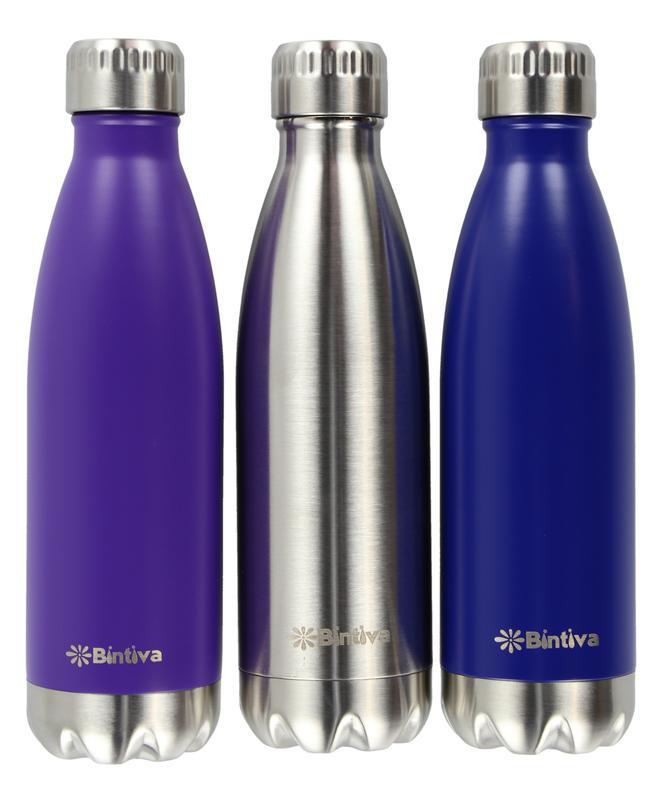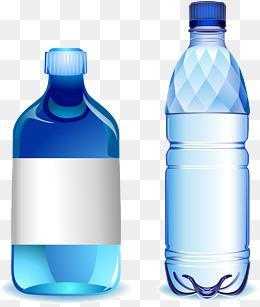The first image is the image on the left, the second image is the image on the right. Evaluate the accuracy of this statement regarding the images: "Each image shows at least five water bottles arranged in an overlapping formation.". Is it true? Answer yes or no. No. The first image is the image on the left, the second image is the image on the right. Considering the images on both sides, is "In the image on the left, all of the bottle are the same size." valid? Answer yes or no. Yes. 